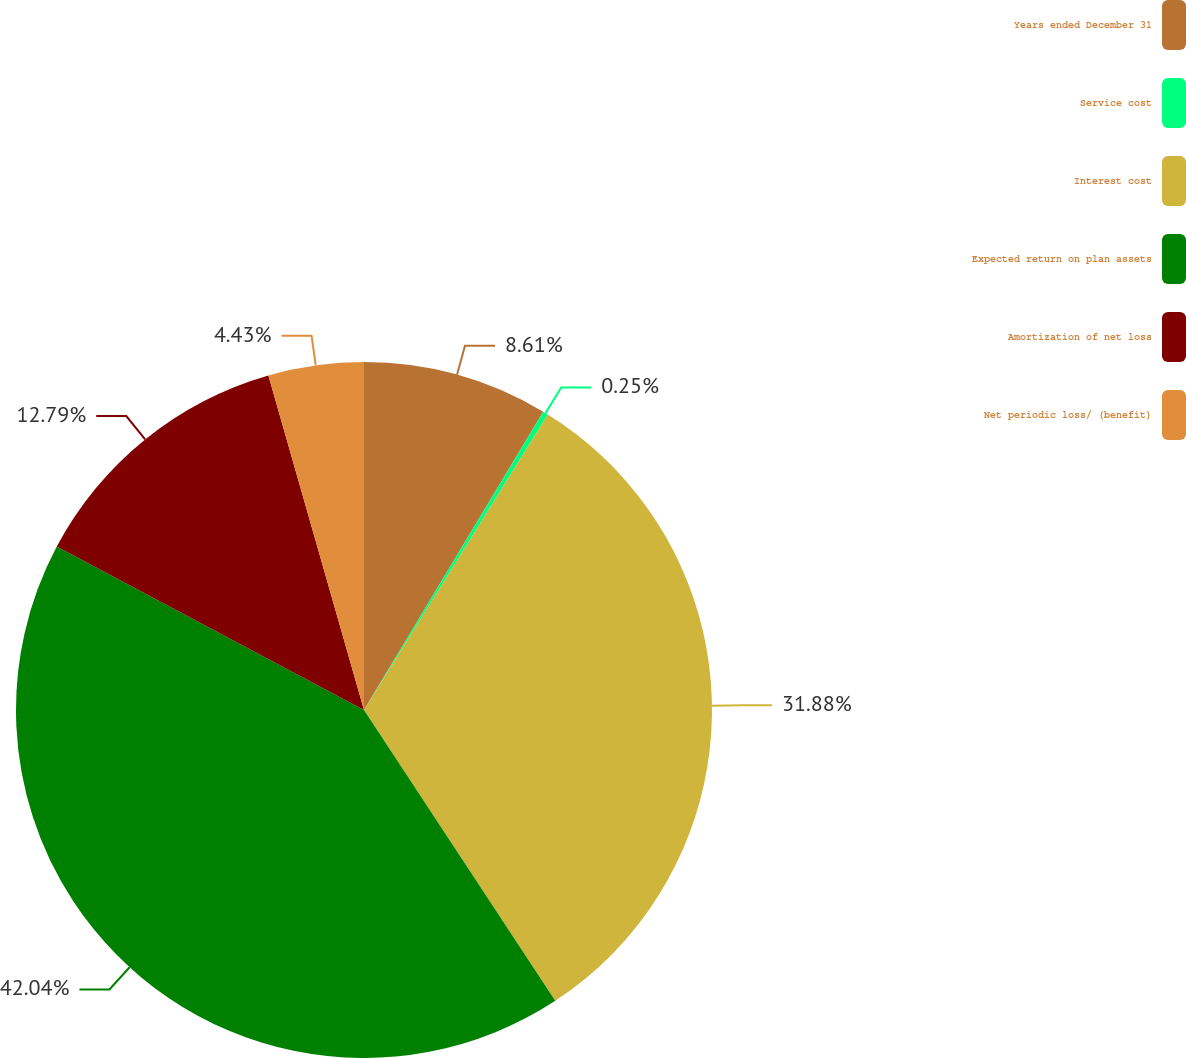<chart> <loc_0><loc_0><loc_500><loc_500><pie_chart><fcel>Years ended December 31<fcel>Service cost<fcel>Interest cost<fcel>Expected return on plan assets<fcel>Amortization of net loss<fcel>Net periodic loss/ (benefit)<nl><fcel>8.61%<fcel>0.25%<fcel>31.88%<fcel>42.04%<fcel>12.79%<fcel>4.43%<nl></chart> 